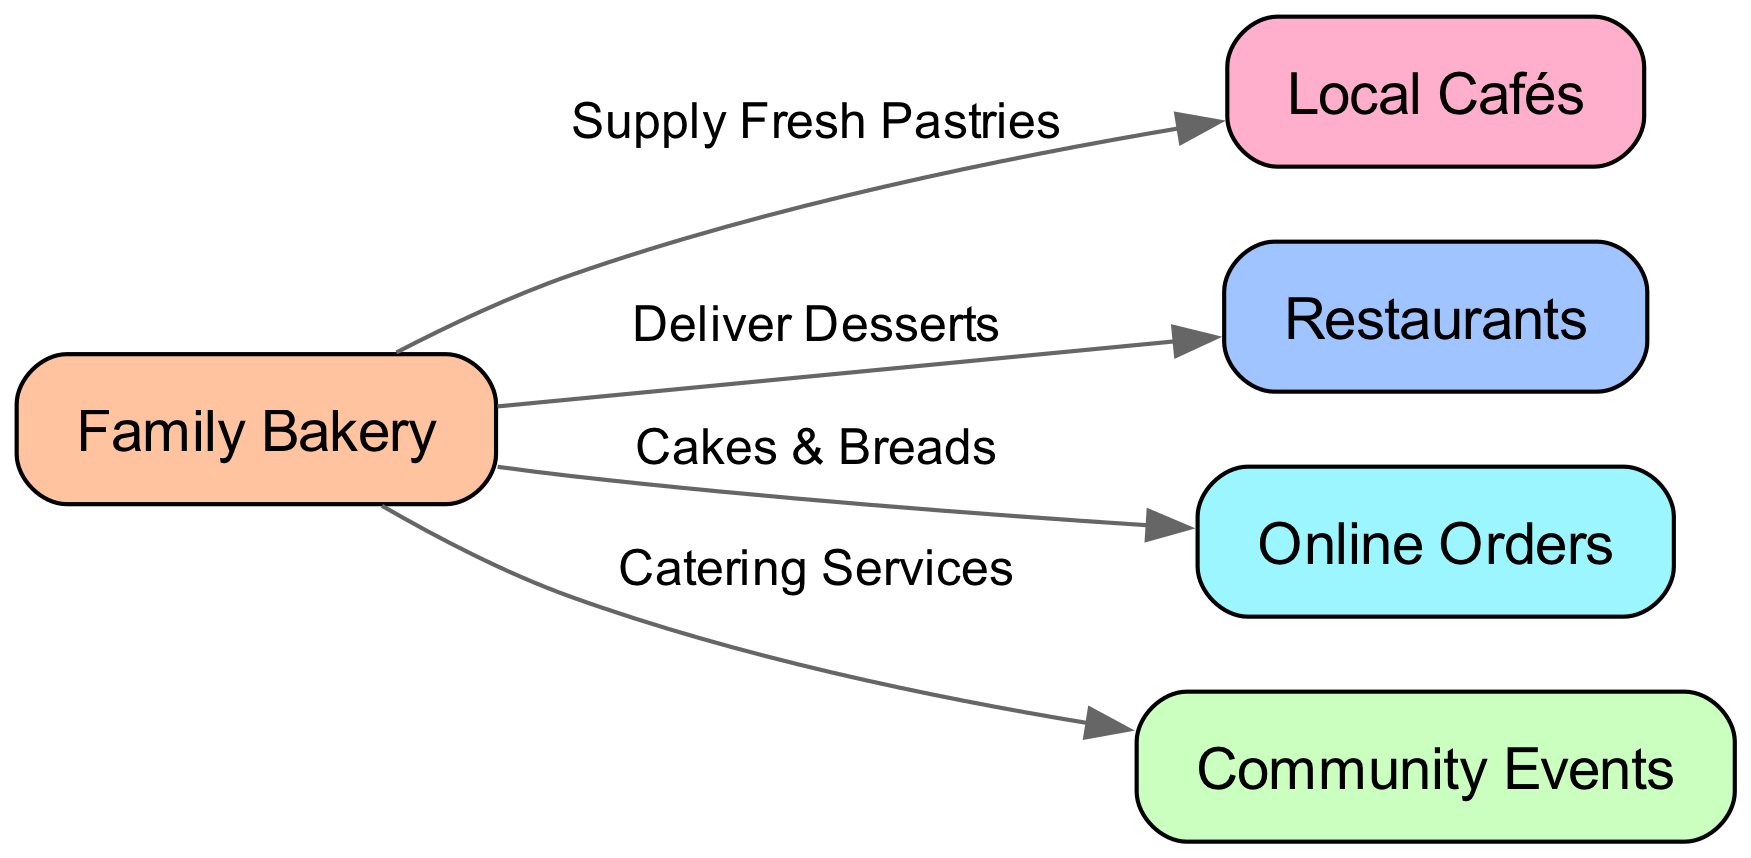What is the starting point of the food chain? The diagram shows that the starting point, which is the source of the supply, is labeled "Family Bakery." This node is the first one listed and connects to various other nodes through edges that indicate the supply paths.
Answer: Family Bakery How many nodes are in the diagram? By counting each unique node in the diagram, we see there are five nodes: Family Bakery, Local Cafés, Restaurants, Online Orders, and Community Events. This total includes all entities involved in the food chain.
Answer: 5 What type of products does the Family Bakery supply to Local Cafés? The edge connecting Family Bakery to Local Cafés is labeled "Supply Fresh Pastries," indicating that the main product supplied to this node is fresh pastries. This is explicitly stated on the diagram.
Answer: Fresh Pastries Which node receives both desserts and catering services from the Family Bakery? By examining the connections from Family Bakery, we find that Restaurants receive desserts ("Deliver Desserts") and also catering services ("Catering Services"). Thus, this node is linked to both edges.
Answer: Restaurants What are the two methods mentioned for delivery from the Family Bakery? The diagram indicates two specific delivery methods from Family Bakery: "Deliver Desserts" to Restaurants and "Cakes & Breads" for Online Orders. This shows the different pathways for bringing products to consumers.
Answer: Deliver Desserts, Cakes & Breads How many edges are there connecting from the Family Bakery? Upon reviewing the diagram, we can see that there are four edges leading from Family Bakery: to Local Cafés, Restaurants, Online Orders, and Community Events. Thus, counting these connections gives us the total.
Answer: 4 Which node provides products for community events? The diagram shows that the edge labeled "Catering Services" connects Family Bakery to the node "Community Events." This implies that products are provided specifically for events in the community.
Answer: Community Events What is the relationship between Family Bakery and Online Orders? The connection from Family Bakery to Online Orders is indicated by the edge labeled "Cakes & Breads," which specifies the type of product delivered to this outlet. This relationship reflects a business model focused on direct sales via online platforms.
Answer: Cakes & Breads 